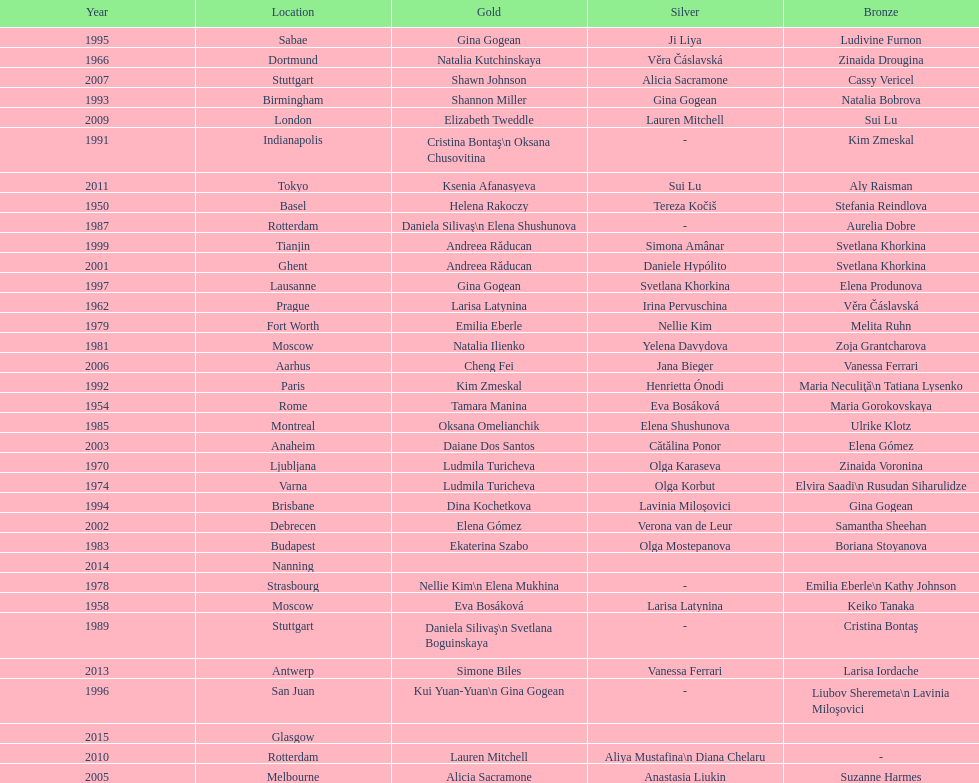Which two american rivals won consecutive floor exercise gold medals at the artistic gymnastics world championships in 1992 and 1993? Kim Zmeskal, Shannon Miller. 